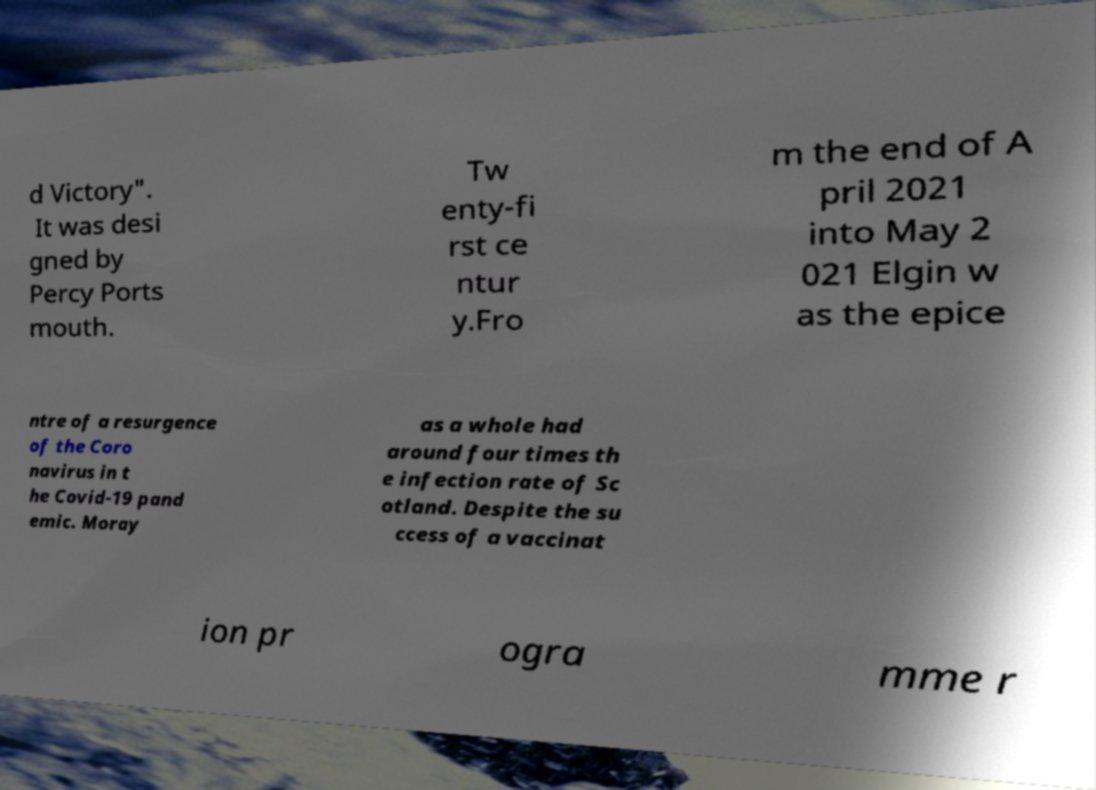Can you read and provide the text displayed in the image?This photo seems to have some interesting text. Can you extract and type it out for me? d Victory". It was desi gned by Percy Ports mouth. Tw enty-fi rst ce ntur y.Fro m the end of A pril 2021 into May 2 021 Elgin w as the epice ntre of a resurgence of the Coro navirus in t he Covid-19 pand emic. Moray as a whole had around four times th e infection rate of Sc otland. Despite the su ccess of a vaccinat ion pr ogra mme r 